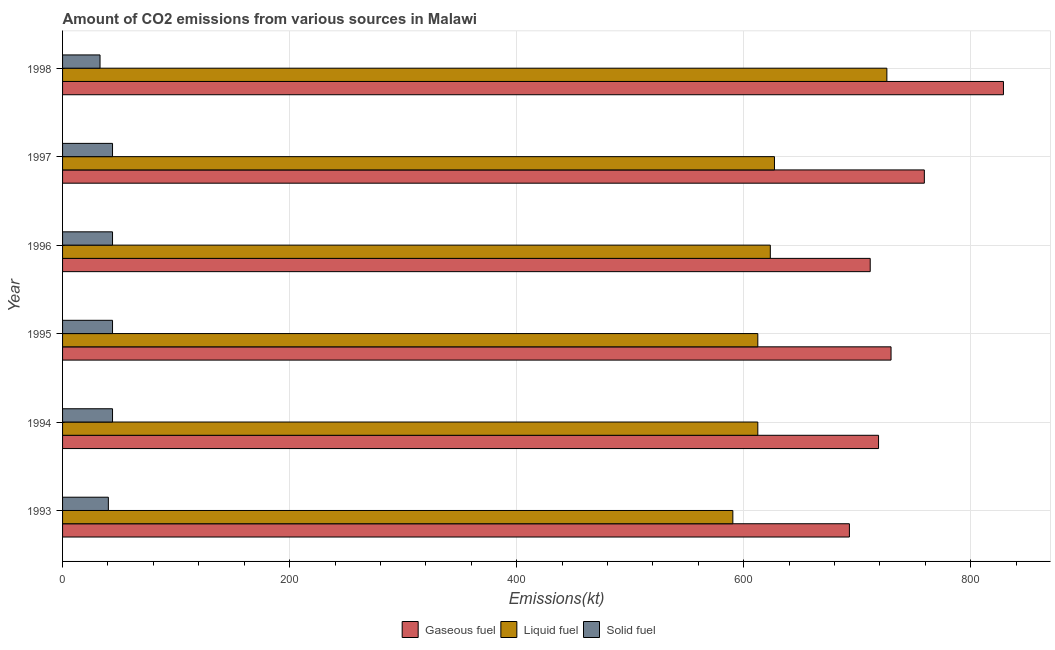How many groups of bars are there?
Your response must be concise. 6. How many bars are there on the 4th tick from the bottom?
Offer a very short reply. 3. In how many cases, is the number of bars for a given year not equal to the number of legend labels?
Offer a terse response. 0. What is the amount of co2 emissions from solid fuel in 1994?
Make the answer very short. 44. Across all years, what is the maximum amount of co2 emissions from gaseous fuel?
Offer a very short reply. 828.74. Across all years, what is the minimum amount of co2 emissions from liquid fuel?
Your response must be concise. 590.39. In which year was the amount of co2 emissions from solid fuel maximum?
Your response must be concise. 1994. What is the total amount of co2 emissions from solid fuel in the graph?
Give a very brief answer. 249.36. What is the difference between the amount of co2 emissions from gaseous fuel in 1993 and that in 1997?
Provide a succinct answer. -66.01. What is the difference between the amount of co2 emissions from solid fuel in 1997 and the amount of co2 emissions from liquid fuel in 1996?
Give a very brief answer. -579.39. What is the average amount of co2 emissions from liquid fuel per year?
Provide a succinct answer. 631.95. In the year 1997, what is the difference between the amount of co2 emissions from solid fuel and amount of co2 emissions from liquid fuel?
Make the answer very short. -583.05. In how many years, is the amount of co2 emissions from liquid fuel greater than 720 kt?
Offer a very short reply. 1. What is the ratio of the amount of co2 emissions from gaseous fuel in 1994 to that in 1998?
Offer a very short reply. 0.87. Is the difference between the amount of co2 emissions from liquid fuel in 1994 and 1998 greater than the difference between the amount of co2 emissions from solid fuel in 1994 and 1998?
Your answer should be very brief. No. What is the difference between the highest and the second highest amount of co2 emissions from liquid fuel?
Keep it short and to the point. 99.01. What is the difference between the highest and the lowest amount of co2 emissions from liquid fuel?
Make the answer very short. 135.68. Is the sum of the amount of co2 emissions from solid fuel in 1993 and 1997 greater than the maximum amount of co2 emissions from liquid fuel across all years?
Ensure brevity in your answer.  No. What does the 1st bar from the top in 1995 represents?
Provide a short and direct response. Solid fuel. What does the 2nd bar from the bottom in 1994 represents?
Offer a very short reply. Liquid fuel. Is it the case that in every year, the sum of the amount of co2 emissions from gaseous fuel and amount of co2 emissions from liquid fuel is greater than the amount of co2 emissions from solid fuel?
Offer a very short reply. Yes. How many bars are there?
Offer a very short reply. 18. What is the difference between two consecutive major ticks on the X-axis?
Provide a short and direct response. 200. Are the values on the major ticks of X-axis written in scientific E-notation?
Your answer should be compact. No. Does the graph contain any zero values?
Ensure brevity in your answer.  No. How many legend labels are there?
Ensure brevity in your answer.  3. What is the title of the graph?
Your response must be concise. Amount of CO2 emissions from various sources in Malawi. What is the label or title of the X-axis?
Your answer should be very brief. Emissions(kt). What is the label or title of the Y-axis?
Keep it short and to the point. Year. What is the Emissions(kt) of Gaseous fuel in 1993?
Your answer should be very brief. 693.06. What is the Emissions(kt) in Liquid fuel in 1993?
Offer a very short reply. 590.39. What is the Emissions(kt) in Solid fuel in 1993?
Your answer should be very brief. 40.34. What is the Emissions(kt) in Gaseous fuel in 1994?
Your response must be concise. 718.73. What is the Emissions(kt) of Liquid fuel in 1994?
Offer a terse response. 612.39. What is the Emissions(kt) in Solid fuel in 1994?
Provide a succinct answer. 44. What is the Emissions(kt) in Gaseous fuel in 1995?
Provide a short and direct response. 729.73. What is the Emissions(kt) of Liquid fuel in 1995?
Offer a terse response. 612.39. What is the Emissions(kt) of Solid fuel in 1995?
Your answer should be compact. 44. What is the Emissions(kt) of Gaseous fuel in 1996?
Make the answer very short. 711.4. What is the Emissions(kt) in Liquid fuel in 1996?
Keep it short and to the point. 623.39. What is the Emissions(kt) of Solid fuel in 1996?
Ensure brevity in your answer.  44. What is the Emissions(kt) of Gaseous fuel in 1997?
Offer a terse response. 759.07. What is the Emissions(kt) in Liquid fuel in 1997?
Offer a very short reply. 627.06. What is the Emissions(kt) of Solid fuel in 1997?
Offer a terse response. 44. What is the Emissions(kt) of Gaseous fuel in 1998?
Your answer should be very brief. 828.74. What is the Emissions(kt) of Liquid fuel in 1998?
Your answer should be compact. 726.07. What is the Emissions(kt) in Solid fuel in 1998?
Offer a very short reply. 33. Across all years, what is the maximum Emissions(kt) in Gaseous fuel?
Your answer should be compact. 828.74. Across all years, what is the maximum Emissions(kt) in Liquid fuel?
Your answer should be compact. 726.07. Across all years, what is the maximum Emissions(kt) in Solid fuel?
Offer a terse response. 44. Across all years, what is the minimum Emissions(kt) in Gaseous fuel?
Offer a terse response. 693.06. Across all years, what is the minimum Emissions(kt) of Liquid fuel?
Your response must be concise. 590.39. Across all years, what is the minimum Emissions(kt) in Solid fuel?
Offer a terse response. 33. What is the total Emissions(kt) of Gaseous fuel in the graph?
Provide a short and direct response. 4440.74. What is the total Emissions(kt) in Liquid fuel in the graph?
Provide a succinct answer. 3791.68. What is the total Emissions(kt) in Solid fuel in the graph?
Your answer should be very brief. 249.36. What is the difference between the Emissions(kt) of Gaseous fuel in 1993 and that in 1994?
Offer a terse response. -25.67. What is the difference between the Emissions(kt) in Liquid fuel in 1993 and that in 1994?
Keep it short and to the point. -22. What is the difference between the Emissions(kt) in Solid fuel in 1993 and that in 1994?
Provide a short and direct response. -3.67. What is the difference between the Emissions(kt) in Gaseous fuel in 1993 and that in 1995?
Your answer should be compact. -36.67. What is the difference between the Emissions(kt) in Liquid fuel in 1993 and that in 1995?
Give a very brief answer. -22. What is the difference between the Emissions(kt) in Solid fuel in 1993 and that in 1995?
Ensure brevity in your answer.  -3.67. What is the difference between the Emissions(kt) in Gaseous fuel in 1993 and that in 1996?
Provide a succinct answer. -18.34. What is the difference between the Emissions(kt) in Liquid fuel in 1993 and that in 1996?
Provide a succinct answer. -33. What is the difference between the Emissions(kt) of Solid fuel in 1993 and that in 1996?
Give a very brief answer. -3.67. What is the difference between the Emissions(kt) of Gaseous fuel in 1993 and that in 1997?
Give a very brief answer. -66.01. What is the difference between the Emissions(kt) in Liquid fuel in 1993 and that in 1997?
Offer a very short reply. -36.67. What is the difference between the Emissions(kt) in Solid fuel in 1993 and that in 1997?
Provide a succinct answer. -3.67. What is the difference between the Emissions(kt) in Gaseous fuel in 1993 and that in 1998?
Provide a succinct answer. -135.68. What is the difference between the Emissions(kt) of Liquid fuel in 1993 and that in 1998?
Your answer should be compact. -135.68. What is the difference between the Emissions(kt) in Solid fuel in 1993 and that in 1998?
Make the answer very short. 7.33. What is the difference between the Emissions(kt) of Gaseous fuel in 1994 and that in 1995?
Provide a succinct answer. -11. What is the difference between the Emissions(kt) of Liquid fuel in 1994 and that in 1995?
Give a very brief answer. 0. What is the difference between the Emissions(kt) in Solid fuel in 1994 and that in 1995?
Offer a very short reply. 0. What is the difference between the Emissions(kt) of Gaseous fuel in 1994 and that in 1996?
Offer a terse response. 7.33. What is the difference between the Emissions(kt) of Liquid fuel in 1994 and that in 1996?
Offer a terse response. -11. What is the difference between the Emissions(kt) in Gaseous fuel in 1994 and that in 1997?
Offer a very short reply. -40.34. What is the difference between the Emissions(kt) in Liquid fuel in 1994 and that in 1997?
Offer a very short reply. -14.67. What is the difference between the Emissions(kt) in Gaseous fuel in 1994 and that in 1998?
Your answer should be very brief. -110.01. What is the difference between the Emissions(kt) of Liquid fuel in 1994 and that in 1998?
Your answer should be compact. -113.68. What is the difference between the Emissions(kt) of Solid fuel in 1994 and that in 1998?
Ensure brevity in your answer.  11. What is the difference between the Emissions(kt) in Gaseous fuel in 1995 and that in 1996?
Keep it short and to the point. 18.34. What is the difference between the Emissions(kt) of Liquid fuel in 1995 and that in 1996?
Keep it short and to the point. -11. What is the difference between the Emissions(kt) of Solid fuel in 1995 and that in 1996?
Provide a succinct answer. 0. What is the difference between the Emissions(kt) in Gaseous fuel in 1995 and that in 1997?
Your response must be concise. -29.34. What is the difference between the Emissions(kt) of Liquid fuel in 1995 and that in 1997?
Keep it short and to the point. -14.67. What is the difference between the Emissions(kt) of Solid fuel in 1995 and that in 1997?
Ensure brevity in your answer.  0. What is the difference between the Emissions(kt) of Gaseous fuel in 1995 and that in 1998?
Keep it short and to the point. -99.01. What is the difference between the Emissions(kt) of Liquid fuel in 1995 and that in 1998?
Ensure brevity in your answer.  -113.68. What is the difference between the Emissions(kt) of Solid fuel in 1995 and that in 1998?
Provide a short and direct response. 11. What is the difference between the Emissions(kt) of Gaseous fuel in 1996 and that in 1997?
Offer a terse response. -47.67. What is the difference between the Emissions(kt) of Liquid fuel in 1996 and that in 1997?
Make the answer very short. -3.67. What is the difference between the Emissions(kt) of Gaseous fuel in 1996 and that in 1998?
Your answer should be very brief. -117.34. What is the difference between the Emissions(kt) in Liquid fuel in 1996 and that in 1998?
Offer a terse response. -102.68. What is the difference between the Emissions(kt) of Solid fuel in 1996 and that in 1998?
Provide a short and direct response. 11. What is the difference between the Emissions(kt) in Gaseous fuel in 1997 and that in 1998?
Offer a terse response. -69.67. What is the difference between the Emissions(kt) in Liquid fuel in 1997 and that in 1998?
Your response must be concise. -99.01. What is the difference between the Emissions(kt) in Solid fuel in 1997 and that in 1998?
Your response must be concise. 11. What is the difference between the Emissions(kt) in Gaseous fuel in 1993 and the Emissions(kt) in Liquid fuel in 1994?
Keep it short and to the point. 80.67. What is the difference between the Emissions(kt) of Gaseous fuel in 1993 and the Emissions(kt) of Solid fuel in 1994?
Your response must be concise. 649.06. What is the difference between the Emissions(kt) of Liquid fuel in 1993 and the Emissions(kt) of Solid fuel in 1994?
Give a very brief answer. 546.38. What is the difference between the Emissions(kt) in Gaseous fuel in 1993 and the Emissions(kt) in Liquid fuel in 1995?
Provide a short and direct response. 80.67. What is the difference between the Emissions(kt) in Gaseous fuel in 1993 and the Emissions(kt) in Solid fuel in 1995?
Keep it short and to the point. 649.06. What is the difference between the Emissions(kt) in Liquid fuel in 1993 and the Emissions(kt) in Solid fuel in 1995?
Provide a short and direct response. 546.38. What is the difference between the Emissions(kt) of Gaseous fuel in 1993 and the Emissions(kt) of Liquid fuel in 1996?
Offer a very short reply. 69.67. What is the difference between the Emissions(kt) in Gaseous fuel in 1993 and the Emissions(kt) in Solid fuel in 1996?
Give a very brief answer. 649.06. What is the difference between the Emissions(kt) in Liquid fuel in 1993 and the Emissions(kt) in Solid fuel in 1996?
Make the answer very short. 546.38. What is the difference between the Emissions(kt) of Gaseous fuel in 1993 and the Emissions(kt) of Liquid fuel in 1997?
Your answer should be compact. 66.01. What is the difference between the Emissions(kt) in Gaseous fuel in 1993 and the Emissions(kt) in Solid fuel in 1997?
Ensure brevity in your answer.  649.06. What is the difference between the Emissions(kt) in Liquid fuel in 1993 and the Emissions(kt) in Solid fuel in 1997?
Give a very brief answer. 546.38. What is the difference between the Emissions(kt) of Gaseous fuel in 1993 and the Emissions(kt) of Liquid fuel in 1998?
Your answer should be very brief. -33. What is the difference between the Emissions(kt) in Gaseous fuel in 1993 and the Emissions(kt) in Solid fuel in 1998?
Provide a succinct answer. 660.06. What is the difference between the Emissions(kt) in Liquid fuel in 1993 and the Emissions(kt) in Solid fuel in 1998?
Give a very brief answer. 557.38. What is the difference between the Emissions(kt) in Gaseous fuel in 1994 and the Emissions(kt) in Liquid fuel in 1995?
Your response must be concise. 106.34. What is the difference between the Emissions(kt) of Gaseous fuel in 1994 and the Emissions(kt) of Solid fuel in 1995?
Offer a terse response. 674.73. What is the difference between the Emissions(kt) in Liquid fuel in 1994 and the Emissions(kt) in Solid fuel in 1995?
Ensure brevity in your answer.  568.38. What is the difference between the Emissions(kt) in Gaseous fuel in 1994 and the Emissions(kt) in Liquid fuel in 1996?
Ensure brevity in your answer.  95.34. What is the difference between the Emissions(kt) in Gaseous fuel in 1994 and the Emissions(kt) in Solid fuel in 1996?
Keep it short and to the point. 674.73. What is the difference between the Emissions(kt) of Liquid fuel in 1994 and the Emissions(kt) of Solid fuel in 1996?
Provide a short and direct response. 568.38. What is the difference between the Emissions(kt) of Gaseous fuel in 1994 and the Emissions(kt) of Liquid fuel in 1997?
Make the answer very short. 91.67. What is the difference between the Emissions(kt) in Gaseous fuel in 1994 and the Emissions(kt) in Solid fuel in 1997?
Provide a short and direct response. 674.73. What is the difference between the Emissions(kt) in Liquid fuel in 1994 and the Emissions(kt) in Solid fuel in 1997?
Offer a terse response. 568.38. What is the difference between the Emissions(kt) in Gaseous fuel in 1994 and the Emissions(kt) in Liquid fuel in 1998?
Ensure brevity in your answer.  -7.33. What is the difference between the Emissions(kt) in Gaseous fuel in 1994 and the Emissions(kt) in Solid fuel in 1998?
Provide a succinct answer. 685.73. What is the difference between the Emissions(kt) of Liquid fuel in 1994 and the Emissions(kt) of Solid fuel in 1998?
Provide a short and direct response. 579.39. What is the difference between the Emissions(kt) of Gaseous fuel in 1995 and the Emissions(kt) of Liquid fuel in 1996?
Offer a terse response. 106.34. What is the difference between the Emissions(kt) in Gaseous fuel in 1995 and the Emissions(kt) in Solid fuel in 1996?
Offer a very short reply. 685.73. What is the difference between the Emissions(kt) in Liquid fuel in 1995 and the Emissions(kt) in Solid fuel in 1996?
Offer a terse response. 568.38. What is the difference between the Emissions(kt) in Gaseous fuel in 1995 and the Emissions(kt) in Liquid fuel in 1997?
Provide a short and direct response. 102.68. What is the difference between the Emissions(kt) in Gaseous fuel in 1995 and the Emissions(kt) in Solid fuel in 1997?
Your response must be concise. 685.73. What is the difference between the Emissions(kt) in Liquid fuel in 1995 and the Emissions(kt) in Solid fuel in 1997?
Make the answer very short. 568.38. What is the difference between the Emissions(kt) in Gaseous fuel in 1995 and the Emissions(kt) in Liquid fuel in 1998?
Ensure brevity in your answer.  3.67. What is the difference between the Emissions(kt) of Gaseous fuel in 1995 and the Emissions(kt) of Solid fuel in 1998?
Offer a very short reply. 696.73. What is the difference between the Emissions(kt) in Liquid fuel in 1995 and the Emissions(kt) in Solid fuel in 1998?
Ensure brevity in your answer.  579.39. What is the difference between the Emissions(kt) of Gaseous fuel in 1996 and the Emissions(kt) of Liquid fuel in 1997?
Provide a short and direct response. 84.34. What is the difference between the Emissions(kt) in Gaseous fuel in 1996 and the Emissions(kt) in Solid fuel in 1997?
Offer a very short reply. 667.39. What is the difference between the Emissions(kt) in Liquid fuel in 1996 and the Emissions(kt) in Solid fuel in 1997?
Offer a very short reply. 579.39. What is the difference between the Emissions(kt) in Gaseous fuel in 1996 and the Emissions(kt) in Liquid fuel in 1998?
Give a very brief answer. -14.67. What is the difference between the Emissions(kt) of Gaseous fuel in 1996 and the Emissions(kt) of Solid fuel in 1998?
Provide a short and direct response. 678.39. What is the difference between the Emissions(kt) in Liquid fuel in 1996 and the Emissions(kt) in Solid fuel in 1998?
Give a very brief answer. 590.39. What is the difference between the Emissions(kt) of Gaseous fuel in 1997 and the Emissions(kt) of Liquid fuel in 1998?
Give a very brief answer. 33. What is the difference between the Emissions(kt) in Gaseous fuel in 1997 and the Emissions(kt) in Solid fuel in 1998?
Ensure brevity in your answer.  726.07. What is the difference between the Emissions(kt) of Liquid fuel in 1997 and the Emissions(kt) of Solid fuel in 1998?
Your response must be concise. 594.05. What is the average Emissions(kt) of Gaseous fuel per year?
Offer a terse response. 740.12. What is the average Emissions(kt) of Liquid fuel per year?
Ensure brevity in your answer.  631.95. What is the average Emissions(kt) of Solid fuel per year?
Provide a short and direct response. 41.56. In the year 1993, what is the difference between the Emissions(kt) of Gaseous fuel and Emissions(kt) of Liquid fuel?
Provide a succinct answer. 102.68. In the year 1993, what is the difference between the Emissions(kt) in Gaseous fuel and Emissions(kt) in Solid fuel?
Ensure brevity in your answer.  652.73. In the year 1993, what is the difference between the Emissions(kt) of Liquid fuel and Emissions(kt) of Solid fuel?
Offer a terse response. 550.05. In the year 1994, what is the difference between the Emissions(kt) of Gaseous fuel and Emissions(kt) of Liquid fuel?
Give a very brief answer. 106.34. In the year 1994, what is the difference between the Emissions(kt) in Gaseous fuel and Emissions(kt) in Solid fuel?
Keep it short and to the point. 674.73. In the year 1994, what is the difference between the Emissions(kt) in Liquid fuel and Emissions(kt) in Solid fuel?
Your response must be concise. 568.38. In the year 1995, what is the difference between the Emissions(kt) in Gaseous fuel and Emissions(kt) in Liquid fuel?
Provide a short and direct response. 117.34. In the year 1995, what is the difference between the Emissions(kt) in Gaseous fuel and Emissions(kt) in Solid fuel?
Provide a succinct answer. 685.73. In the year 1995, what is the difference between the Emissions(kt) of Liquid fuel and Emissions(kt) of Solid fuel?
Ensure brevity in your answer.  568.38. In the year 1996, what is the difference between the Emissions(kt) in Gaseous fuel and Emissions(kt) in Liquid fuel?
Provide a succinct answer. 88.01. In the year 1996, what is the difference between the Emissions(kt) of Gaseous fuel and Emissions(kt) of Solid fuel?
Your answer should be very brief. 667.39. In the year 1996, what is the difference between the Emissions(kt) in Liquid fuel and Emissions(kt) in Solid fuel?
Your answer should be compact. 579.39. In the year 1997, what is the difference between the Emissions(kt) in Gaseous fuel and Emissions(kt) in Liquid fuel?
Ensure brevity in your answer.  132.01. In the year 1997, what is the difference between the Emissions(kt) of Gaseous fuel and Emissions(kt) of Solid fuel?
Provide a succinct answer. 715.07. In the year 1997, what is the difference between the Emissions(kt) in Liquid fuel and Emissions(kt) in Solid fuel?
Your answer should be compact. 583.05. In the year 1998, what is the difference between the Emissions(kt) in Gaseous fuel and Emissions(kt) in Liquid fuel?
Keep it short and to the point. 102.68. In the year 1998, what is the difference between the Emissions(kt) of Gaseous fuel and Emissions(kt) of Solid fuel?
Give a very brief answer. 795.74. In the year 1998, what is the difference between the Emissions(kt) in Liquid fuel and Emissions(kt) in Solid fuel?
Make the answer very short. 693.06. What is the ratio of the Emissions(kt) in Gaseous fuel in 1993 to that in 1994?
Your response must be concise. 0.96. What is the ratio of the Emissions(kt) of Liquid fuel in 1993 to that in 1994?
Your answer should be very brief. 0.96. What is the ratio of the Emissions(kt) in Gaseous fuel in 1993 to that in 1995?
Provide a succinct answer. 0.95. What is the ratio of the Emissions(kt) of Liquid fuel in 1993 to that in 1995?
Keep it short and to the point. 0.96. What is the ratio of the Emissions(kt) in Gaseous fuel in 1993 to that in 1996?
Give a very brief answer. 0.97. What is the ratio of the Emissions(kt) in Liquid fuel in 1993 to that in 1996?
Your answer should be very brief. 0.95. What is the ratio of the Emissions(kt) of Liquid fuel in 1993 to that in 1997?
Make the answer very short. 0.94. What is the ratio of the Emissions(kt) in Solid fuel in 1993 to that in 1997?
Provide a succinct answer. 0.92. What is the ratio of the Emissions(kt) of Gaseous fuel in 1993 to that in 1998?
Make the answer very short. 0.84. What is the ratio of the Emissions(kt) in Liquid fuel in 1993 to that in 1998?
Provide a succinct answer. 0.81. What is the ratio of the Emissions(kt) of Solid fuel in 1993 to that in 1998?
Your response must be concise. 1.22. What is the ratio of the Emissions(kt) of Gaseous fuel in 1994 to that in 1995?
Your response must be concise. 0.98. What is the ratio of the Emissions(kt) in Gaseous fuel in 1994 to that in 1996?
Your response must be concise. 1.01. What is the ratio of the Emissions(kt) of Liquid fuel in 1994 to that in 1996?
Give a very brief answer. 0.98. What is the ratio of the Emissions(kt) of Gaseous fuel in 1994 to that in 1997?
Make the answer very short. 0.95. What is the ratio of the Emissions(kt) of Liquid fuel in 1994 to that in 1997?
Make the answer very short. 0.98. What is the ratio of the Emissions(kt) in Gaseous fuel in 1994 to that in 1998?
Ensure brevity in your answer.  0.87. What is the ratio of the Emissions(kt) of Liquid fuel in 1994 to that in 1998?
Your answer should be compact. 0.84. What is the ratio of the Emissions(kt) in Gaseous fuel in 1995 to that in 1996?
Keep it short and to the point. 1.03. What is the ratio of the Emissions(kt) in Liquid fuel in 1995 to that in 1996?
Keep it short and to the point. 0.98. What is the ratio of the Emissions(kt) of Gaseous fuel in 1995 to that in 1997?
Give a very brief answer. 0.96. What is the ratio of the Emissions(kt) in Liquid fuel in 1995 to that in 1997?
Keep it short and to the point. 0.98. What is the ratio of the Emissions(kt) in Solid fuel in 1995 to that in 1997?
Offer a very short reply. 1. What is the ratio of the Emissions(kt) in Gaseous fuel in 1995 to that in 1998?
Your answer should be very brief. 0.88. What is the ratio of the Emissions(kt) in Liquid fuel in 1995 to that in 1998?
Keep it short and to the point. 0.84. What is the ratio of the Emissions(kt) in Solid fuel in 1995 to that in 1998?
Offer a terse response. 1.33. What is the ratio of the Emissions(kt) in Gaseous fuel in 1996 to that in 1997?
Keep it short and to the point. 0.94. What is the ratio of the Emissions(kt) of Liquid fuel in 1996 to that in 1997?
Offer a very short reply. 0.99. What is the ratio of the Emissions(kt) of Solid fuel in 1996 to that in 1997?
Provide a short and direct response. 1. What is the ratio of the Emissions(kt) in Gaseous fuel in 1996 to that in 1998?
Keep it short and to the point. 0.86. What is the ratio of the Emissions(kt) in Liquid fuel in 1996 to that in 1998?
Your answer should be very brief. 0.86. What is the ratio of the Emissions(kt) in Gaseous fuel in 1997 to that in 1998?
Give a very brief answer. 0.92. What is the ratio of the Emissions(kt) of Liquid fuel in 1997 to that in 1998?
Make the answer very short. 0.86. What is the ratio of the Emissions(kt) of Solid fuel in 1997 to that in 1998?
Your answer should be very brief. 1.33. What is the difference between the highest and the second highest Emissions(kt) in Gaseous fuel?
Offer a very short reply. 69.67. What is the difference between the highest and the second highest Emissions(kt) of Liquid fuel?
Ensure brevity in your answer.  99.01. What is the difference between the highest and the lowest Emissions(kt) of Gaseous fuel?
Provide a succinct answer. 135.68. What is the difference between the highest and the lowest Emissions(kt) of Liquid fuel?
Keep it short and to the point. 135.68. What is the difference between the highest and the lowest Emissions(kt) in Solid fuel?
Offer a terse response. 11. 